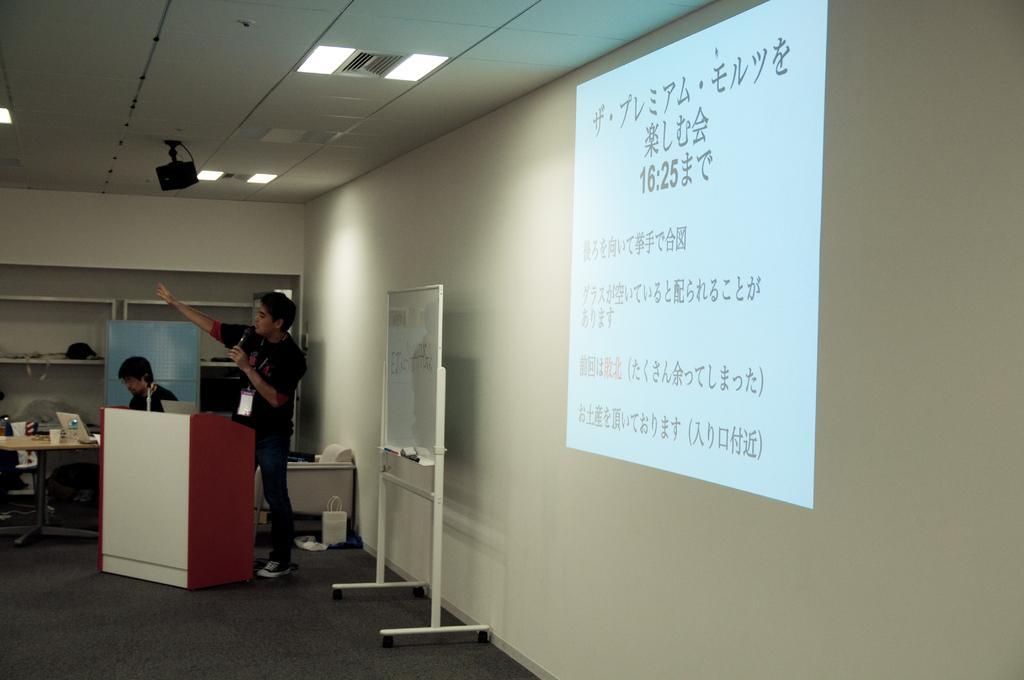Please provide a concise description of this image. The image looks like it is a meeting room. To the right, there is a wall on which a screen is projected. In the middle there is a board. In the front, there is a podium, behind which a man is standing and talking. In the background, there is a wall in white color. At the top there is a roof to with lights and speaker are fixed. 